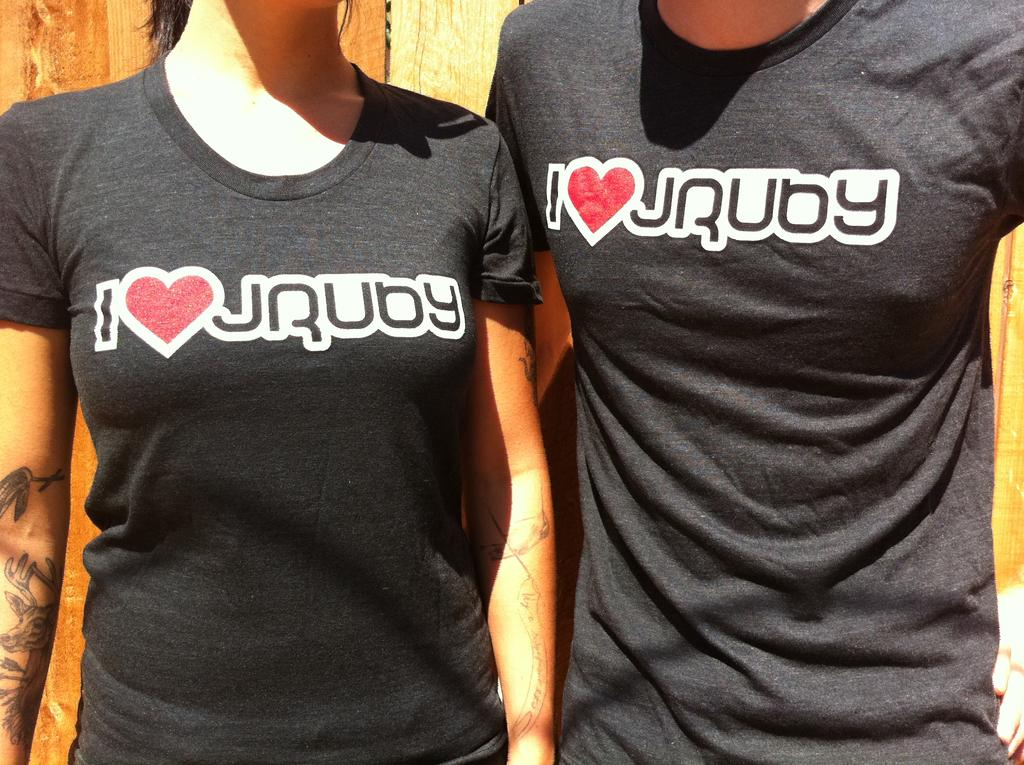<image>
Create a compact narrative representing the image presented. the word ruby is on the shirt of a person 